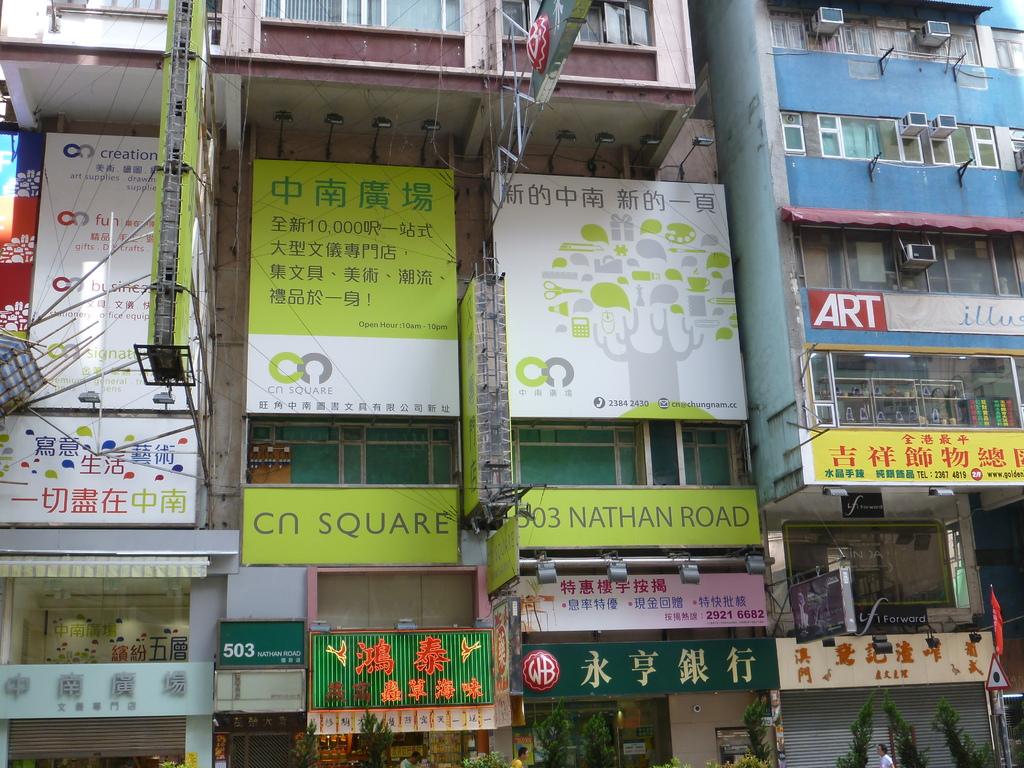What is the name of the square according to the light green banner?
Provide a succinct answer. Cn. What road is this on?
Offer a terse response. Nathan road. 